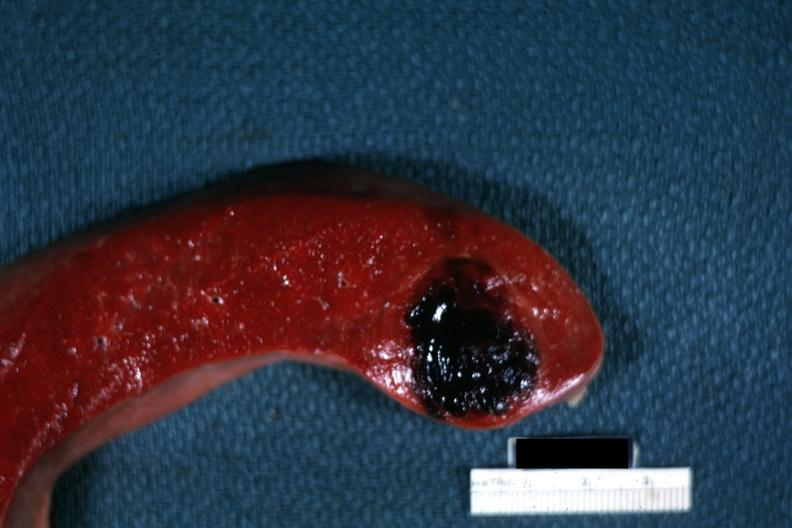s hemangioma present?
Answer the question using a single word or phrase. Yes 